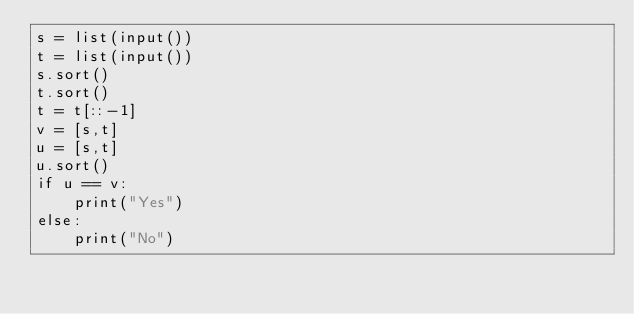Convert code to text. <code><loc_0><loc_0><loc_500><loc_500><_Python_>s = list(input())
t = list(input())
s.sort()
t.sort()
t = t[::-1]
v = [s,t]
u = [s,t]
u.sort()
if u == v:
    print("Yes")
else:
    print("No")</code> 